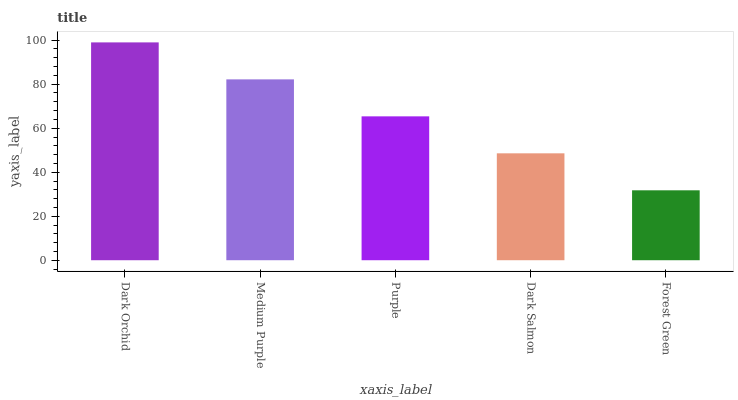Is Medium Purple the minimum?
Answer yes or no. No. Is Medium Purple the maximum?
Answer yes or no. No. Is Dark Orchid greater than Medium Purple?
Answer yes or no. Yes. Is Medium Purple less than Dark Orchid?
Answer yes or no. Yes. Is Medium Purple greater than Dark Orchid?
Answer yes or no. No. Is Dark Orchid less than Medium Purple?
Answer yes or no. No. Is Purple the high median?
Answer yes or no. Yes. Is Purple the low median?
Answer yes or no. Yes. Is Dark Orchid the high median?
Answer yes or no. No. Is Medium Purple the low median?
Answer yes or no. No. 